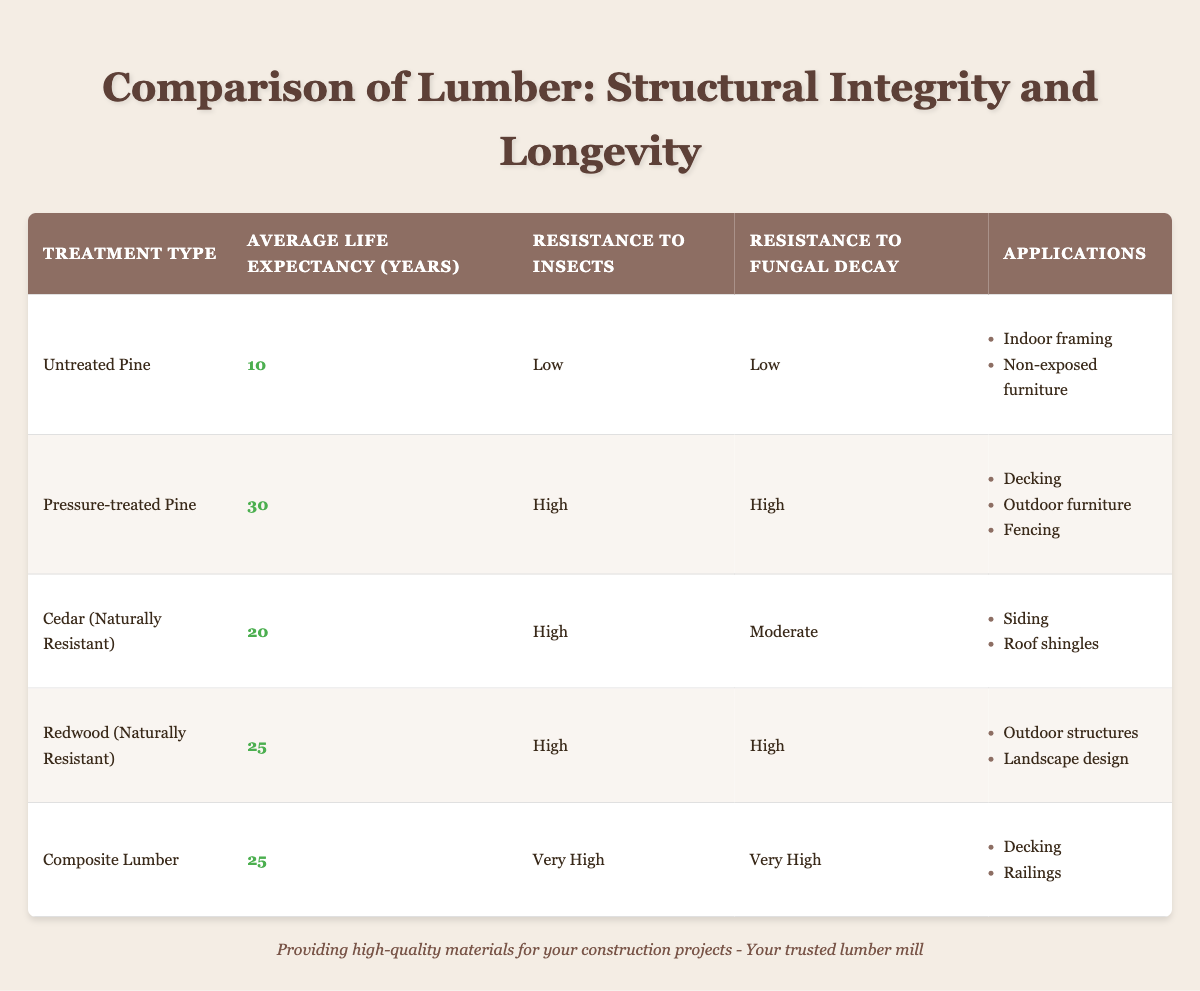What is the average life expectancy of untreated pine? The average life expectancy for untreated pine is directly provided in the table as 10 years.
Answer: 10 years How many years longer does pressure-treated pine last compared to untreated pine? The life expectancy for pressure-treated pine is 30 years while untreated pine is 10 years. The difference is 30 - 10 = 20 years.
Answer: 20 years Is cedar resistant to insects? The table indicates that cedar has a high resistance to insects.
Answer: Yes Which lumber type has the highest resistance to fungal decay? Composite lumber is indicated as having "Very High" resistance to fungal decay, which is the highest rating shown in the table compared to others.
Answer: Composite Lumber Is the resistance to insects for redwood equal to the resistance to insects for untreated pine? The table shows redwood has high resistance to insects and untreated pine has low resistance. Therefore, they are not equal.
Answer: No What is the average life expectancy of all the lumber types listed in the table? To find the average, sum the life expectancies: 10 + 30 + 20 + 25 + 25 = 110 years. There are 5 lumber types, so the average is 110 / 5 = 22 years.
Answer: 22 years Which lumber types can be used for outdoor structures? According to the table, both pressure-treated pine and redwood can be used for outdoor structures. This information is found under the applications section.
Answer: Pressure-treated Pine and Redwood What is the total number of years of life expectancy for treated lumber types only? The treated lumber types are pressure-treated pine, cedar, redwood, and composite lumber. Their life expectancies are: 30, 20, 25, and 25 years respectively. Adding these gives 30 + 20 + 25 + 25 = 100 years.
Answer: 100 years Does untreated pine have applications suitable for outdoor use? The table specifies that untreated pine is for indoor framing and non-exposed furniture, indicating that it is not suitable for outdoor applications.
Answer: No 